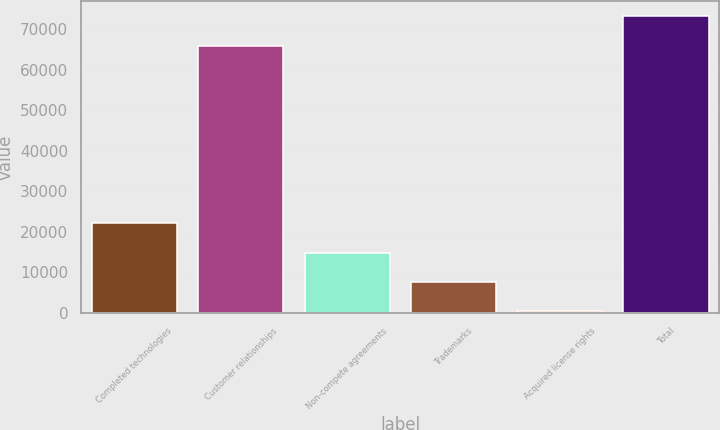Convert chart. <chart><loc_0><loc_0><loc_500><loc_500><bar_chart><fcel>Completed technologies<fcel>Customer relationships<fcel>Non-compete agreements<fcel>Trademarks<fcel>Acquired license rights<fcel>Total<nl><fcel>22120<fcel>65900<fcel>14910<fcel>7700<fcel>490<fcel>73110<nl></chart> 